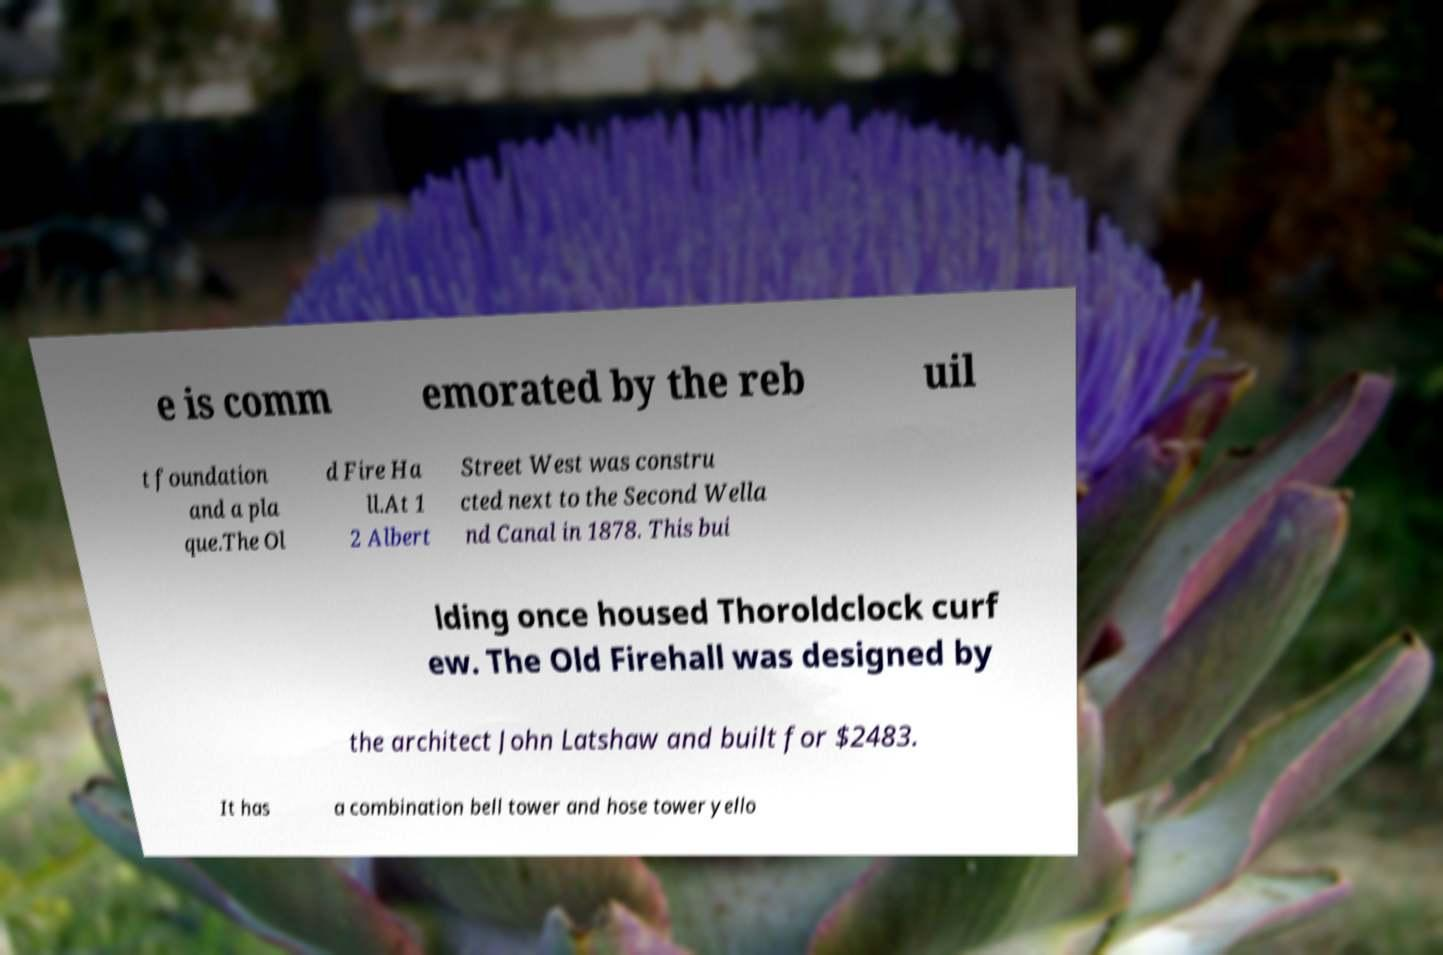Could you assist in decoding the text presented in this image and type it out clearly? e is comm emorated by the reb uil t foundation and a pla que.The Ol d Fire Ha ll.At 1 2 Albert Street West was constru cted next to the Second Wella nd Canal in 1878. This bui lding once housed Thoroldclock curf ew. The Old Firehall was designed by the architect John Latshaw and built for $2483. It has a combination bell tower and hose tower yello 